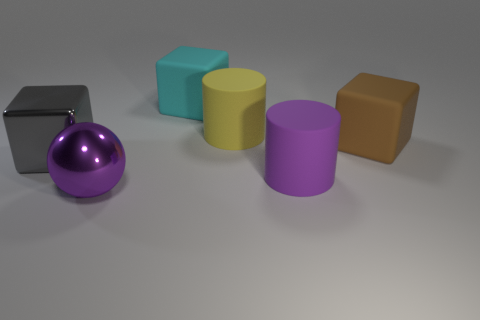Subtract all big matte cubes. How many cubes are left? 1 Subtract 1 blocks. How many blocks are left? 2 Add 2 green metallic things. How many objects exist? 8 Subtract all cylinders. How many objects are left? 4 Subtract all rubber objects. Subtract all big gray blocks. How many objects are left? 1 Add 4 big cyan matte blocks. How many big cyan matte blocks are left? 5 Add 5 gray objects. How many gray objects exist? 6 Subtract 0 red blocks. How many objects are left? 6 